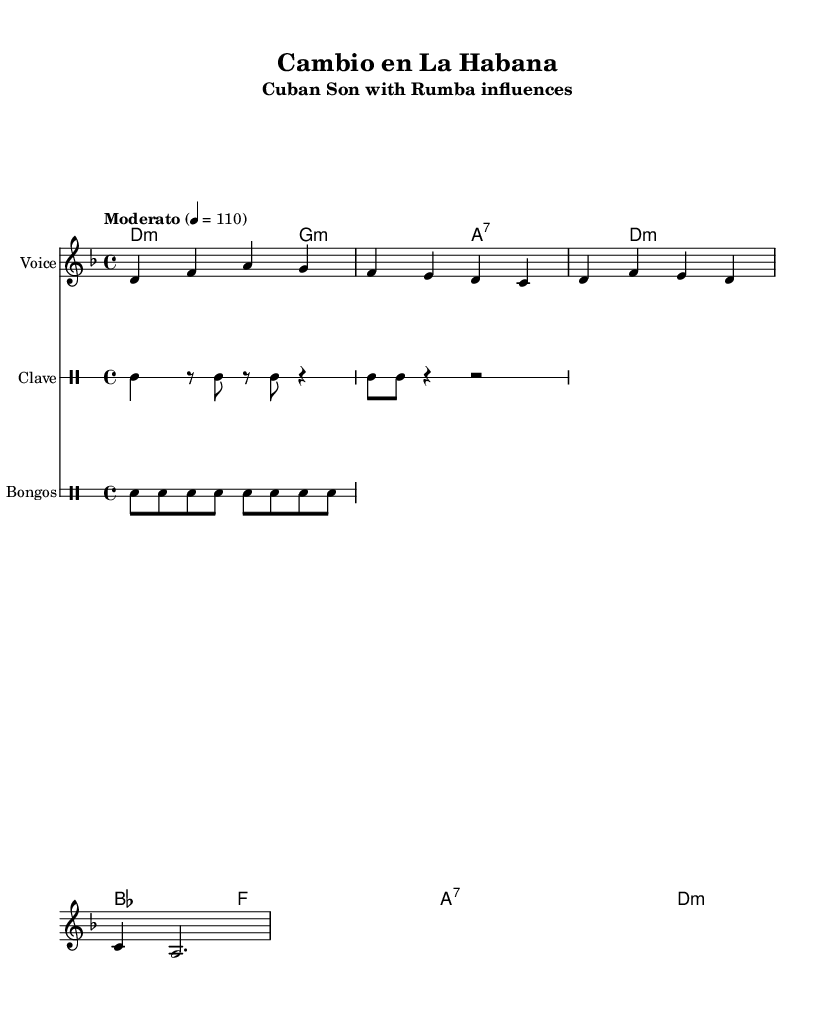What is the key signature of this music? The key signature is defined at the beginning of the score, and in this case, it indicates D minor, which has one flat (B flat).
Answer: D minor What is the time signature of this piece? The time signature can be found at the start of the score; here, it is 4/4, meaning there are four beats in each measure and the quarter note gets one beat.
Answer: 4/4 What is the tempo marking for the song? The tempo marking is specified in the score, and it states "Moderato," which typically indicates a moderate tempo, specifically noted as 110 beats per minute.
Answer: Moderato 4 = 110 How many measures are in the melody section? To determine the number of measures, I will count the distinct sets of bars in the melody staff. There are four measures in total when counting each separated bar grouping.
Answer: 4 What are the primary rhythms used by the drums? The rhythms are outlined in the drum sections. The clave rhythm consists of alternating strong and weak beats, while the bongos use a consistent pattern. Together, these represent fundamental Afro-Cuban rhythms.
Answer: Clave and Bongo rhythms What does the title of the piece suggest about its themes? The title "Cambio en La Habana" translates to "Change in Havana," suggesting themes of social change and cultural evolution, likely influenced by the socio-political dynamics of 1930s Cuba.
Answer: Social change What musical form is commonly associated with Cuban son and rumba? Cuban son often employs a verse-chorus structure, while rumba integrates call-and-response elements. Both forms reflect their African and Spanish roots, emphasizing rhythm and community.
Answer: Verse-chorus 